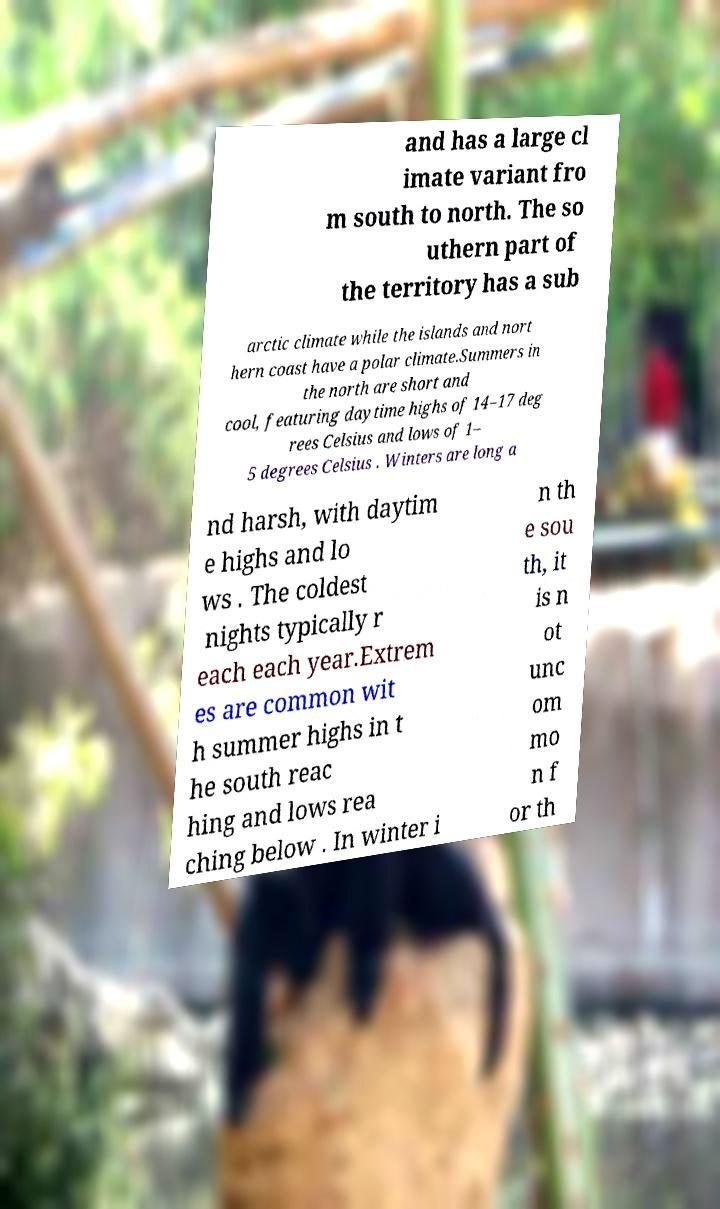What messages or text are displayed in this image? I need them in a readable, typed format. and has a large cl imate variant fro m south to north. The so uthern part of the territory has a sub arctic climate while the islands and nort hern coast have a polar climate.Summers in the north are short and cool, featuring daytime highs of 14–17 deg rees Celsius and lows of 1– 5 degrees Celsius . Winters are long a nd harsh, with daytim e highs and lo ws . The coldest nights typically r each each year.Extrem es are common wit h summer highs in t he south reac hing and lows rea ching below . In winter i n th e sou th, it is n ot unc om mo n f or th 